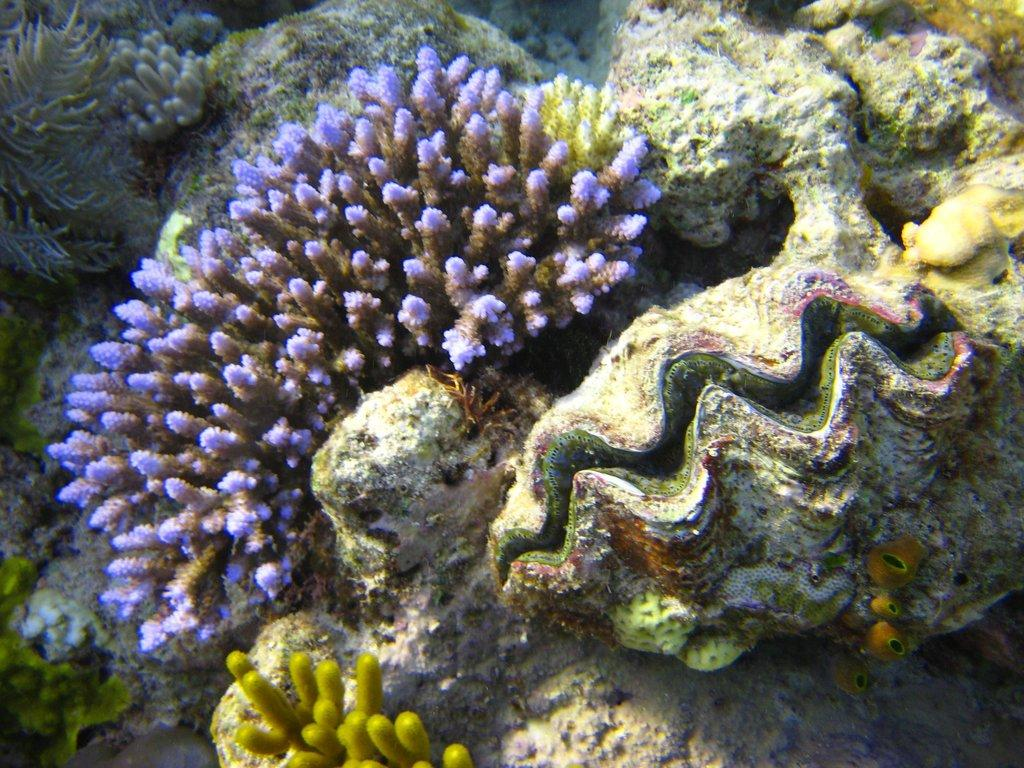What type of environment is shown in the image? The image depicts an underwater environment. What can be found in this underwater environment? There are coral reefs and rocks in the image. Can you see any bears in the image? No, there are no bears present in the underwater image. 